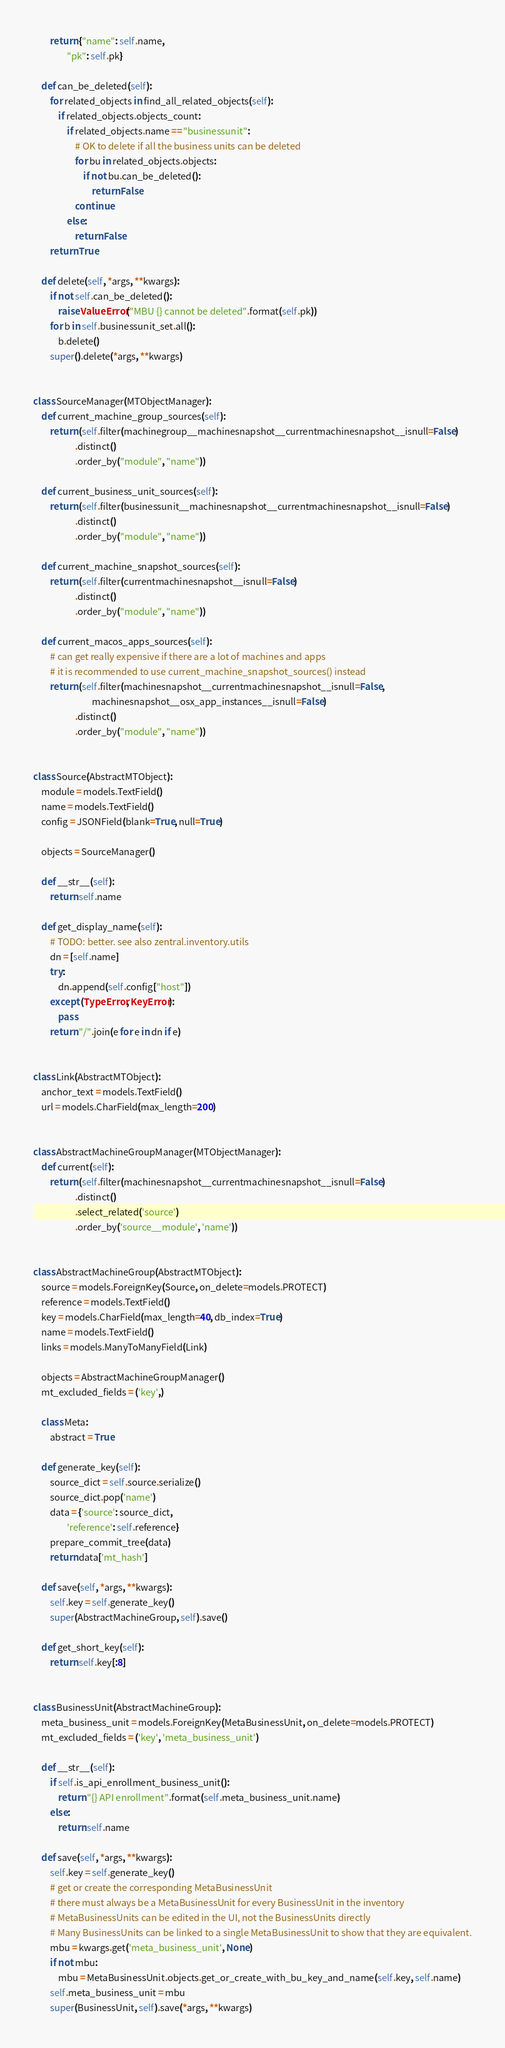Convert code to text. <code><loc_0><loc_0><loc_500><loc_500><_Python_>        return {"name": self.name,
                "pk": self.pk}

    def can_be_deleted(self):
        for related_objects in find_all_related_objects(self):
            if related_objects.objects_count:
                if related_objects.name == "businessunit":
                    # OK to delete if all the business units can be deleted
                    for bu in related_objects.objects:
                        if not bu.can_be_deleted():
                            return False
                    continue
                else:
                    return False
        return True

    def delete(self, *args, **kwargs):
        if not self.can_be_deleted():
            raise ValueError("MBU {} cannot be deleted".format(self.pk))
        for b in self.businessunit_set.all():
            b.delete()
        super().delete(*args, **kwargs)


class SourceManager(MTObjectManager):
    def current_machine_group_sources(self):
        return (self.filter(machinegroup__machinesnapshot__currentmachinesnapshot__isnull=False)
                    .distinct()
                    .order_by("module", "name"))

    def current_business_unit_sources(self):
        return (self.filter(businessunit__machinesnapshot__currentmachinesnapshot__isnull=False)
                    .distinct()
                    .order_by("module", "name"))

    def current_machine_snapshot_sources(self):
        return (self.filter(currentmachinesnapshot__isnull=False)
                    .distinct()
                    .order_by("module", "name"))

    def current_macos_apps_sources(self):
        # can get really expensive if there are a lot of machines and apps
        # it is recommended to use current_machine_snapshot_sources() instead
        return (self.filter(machinesnapshot__currentmachinesnapshot__isnull=False,
                            machinesnapshot__osx_app_instances__isnull=False)
                    .distinct()
                    .order_by("module", "name"))


class Source(AbstractMTObject):
    module = models.TextField()
    name = models.TextField()
    config = JSONField(blank=True, null=True)

    objects = SourceManager()

    def __str__(self):
        return self.name

    def get_display_name(self):
        # TODO: better. see also zentral.inventory.utils
        dn = [self.name]
        try:
            dn.append(self.config["host"])
        except (TypeError, KeyError):
            pass
        return "/".join(e for e in dn if e)


class Link(AbstractMTObject):
    anchor_text = models.TextField()
    url = models.CharField(max_length=200)


class AbstractMachineGroupManager(MTObjectManager):
    def current(self):
        return (self.filter(machinesnapshot__currentmachinesnapshot__isnull=False)
                    .distinct()
                    .select_related('source')
                    .order_by('source__module', 'name'))


class AbstractMachineGroup(AbstractMTObject):
    source = models.ForeignKey(Source, on_delete=models.PROTECT)
    reference = models.TextField()
    key = models.CharField(max_length=40, db_index=True)
    name = models.TextField()
    links = models.ManyToManyField(Link)

    objects = AbstractMachineGroupManager()
    mt_excluded_fields = ('key',)

    class Meta:
        abstract = True

    def generate_key(self):
        source_dict = self.source.serialize()
        source_dict.pop('name')
        data = {'source': source_dict,
                'reference': self.reference}
        prepare_commit_tree(data)
        return data['mt_hash']

    def save(self, *args, **kwargs):
        self.key = self.generate_key()
        super(AbstractMachineGroup, self).save()

    def get_short_key(self):
        return self.key[:8]


class BusinessUnit(AbstractMachineGroup):
    meta_business_unit = models.ForeignKey(MetaBusinessUnit, on_delete=models.PROTECT)
    mt_excluded_fields = ('key', 'meta_business_unit')

    def __str__(self):
        if self.is_api_enrollment_business_unit():
            return "{} API enrollment".format(self.meta_business_unit.name)
        else:
            return self.name

    def save(self, *args, **kwargs):
        self.key = self.generate_key()
        # get or create the corresponding MetaBusinessUnit
        # there must always be a MetaBusinessUnit for every BusinessUnit in the inventory
        # MetaBusinessUnits can be edited in the UI, not the BusinessUnits directly
        # Many BusinessUnits can be linked to a single MetaBusinessUnit to show that they are equivalent.
        mbu = kwargs.get('meta_business_unit', None)
        if not mbu:
            mbu = MetaBusinessUnit.objects.get_or_create_with_bu_key_and_name(self.key, self.name)
        self.meta_business_unit = mbu
        super(BusinessUnit, self).save(*args, **kwargs)
</code> 